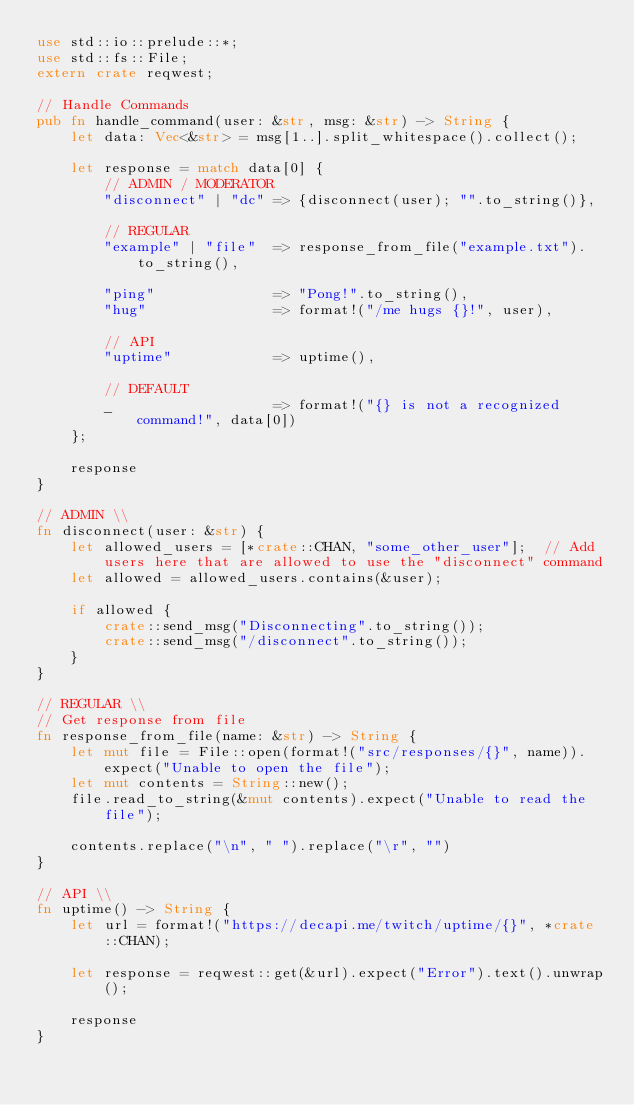Convert code to text. <code><loc_0><loc_0><loc_500><loc_500><_Rust_>use std::io::prelude::*;
use std::fs::File;
extern crate reqwest;

// Handle Commands
pub fn handle_command(user: &str, msg: &str) -> String {
    let data: Vec<&str> = msg[1..].split_whitespace().collect();

    let response = match data[0] {
        // ADMIN / MODERATOR
        "disconnect" | "dc" => {disconnect(user); "".to_string()},

        // REGULAR
        "example" | "file"  => response_from_file("example.txt").to_string(),

        "ping"              => "Pong!".to_string(),
        "hug"               => format!("/me hugs {}!", user),

        // API
        "uptime"            => uptime(),

        // DEFAULT
        _                   => format!("{} is not a recognized command!", data[0])
    };

    response
}

// ADMIN \\
fn disconnect(user: &str) {
    let allowed_users = [*crate::CHAN, "some_other_user"];  // Add users here that are allowed to use the "disconnect" command
    let allowed = allowed_users.contains(&user);

    if allowed {
        crate::send_msg("Disconnecting".to_string());
        crate::send_msg("/disconnect".to_string());
    }
}

// REGULAR \\
// Get response from file
fn response_from_file(name: &str) -> String {
    let mut file = File::open(format!("src/responses/{}", name)).expect("Unable to open the file");
    let mut contents = String::new();
    file.read_to_string(&mut contents).expect("Unable to read the file");

    contents.replace("\n", " ").replace("\r", "")
}

// API \\
fn uptime() -> String {
    let url = format!("https://decapi.me/twitch/uptime/{}", *crate::CHAN);

    let response = reqwest::get(&url).expect("Error").text().unwrap();

    response
}
</code> 